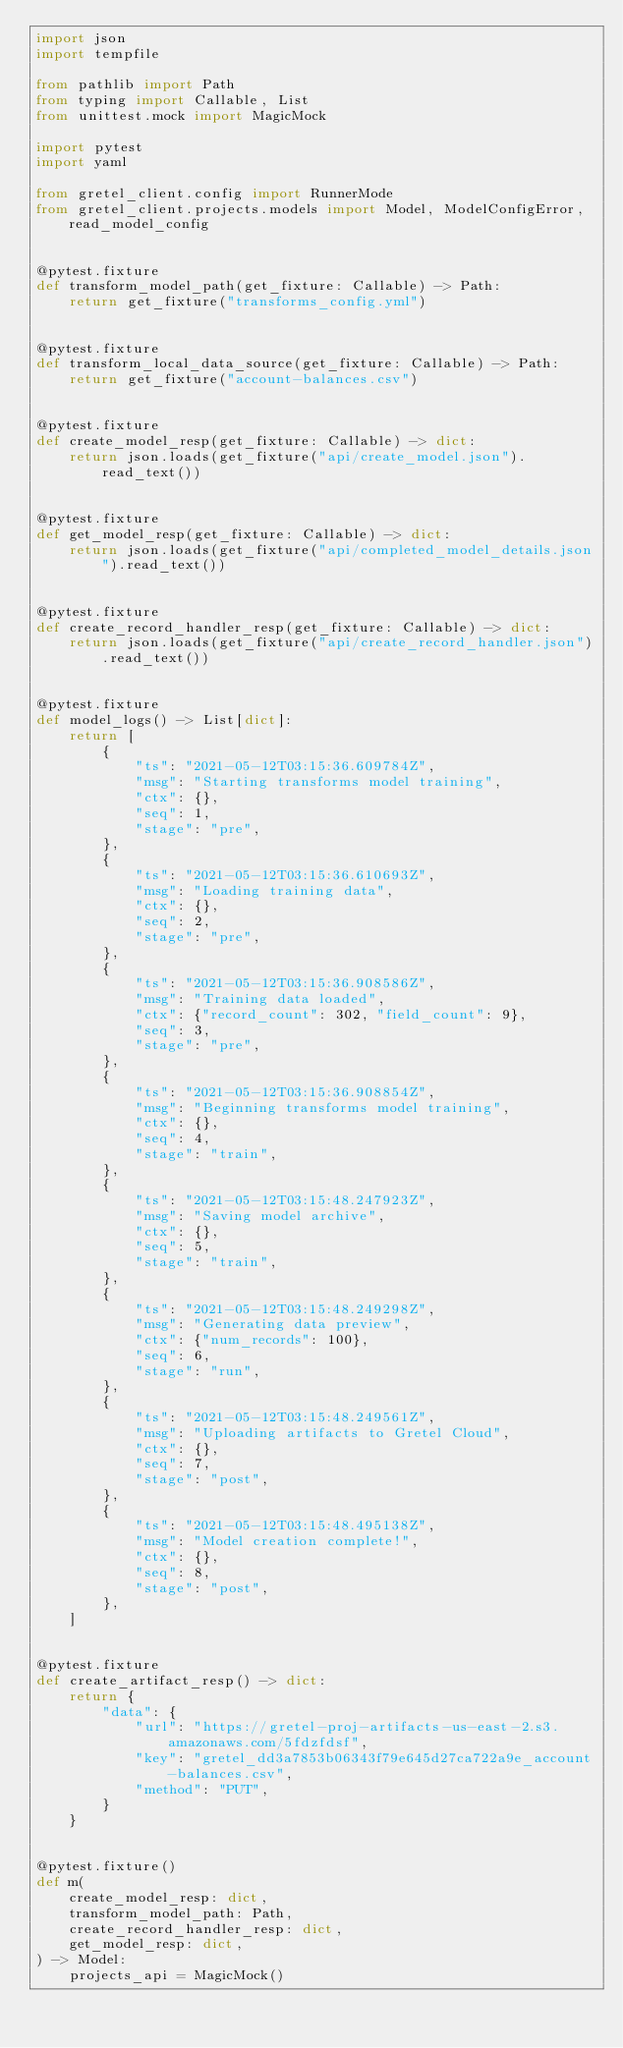<code> <loc_0><loc_0><loc_500><loc_500><_Python_>import json
import tempfile

from pathlib import Path
from typing import Callable, List
from unittest.mock import MagicMock

import pytest
import yaml

from gretel_client.config import RunnerMode
from gretel_client.projects.models import Model, ModelConfigError, read_model_config


@pytest.fixture
def transform_model_path(get_fixture: Callable) -> Path:
    return get_fixture("transforms_config.yml")


@pytest.fixture
def transform_local_data_source(get_fixture: Callable) -> Path:
    return get_fixture("account-balances.csv")


@pytest.fixture
def create_model_resp(get_fixture: Callable) -> dict:
    return json.loads(get_fixture("api/create_model.json").read_text())


@pytest.fixture
def get_model_resp(get_fixture: Callable) -> dict:
    return json.loads(get_fixture("api/completed_model_details.json").read_text())


@pytest.fixture
def create_record_handler_resp(get_fixture: Callable) -> dict:
    return json.loads(get_fixture("api/create_record_handler.json").read_text())


@pytest.fixture
def model_logs() -> List[dict]:
    return [
        {
            "ts": "2021-05-12T03:15:36.609784Z",
            "msg": "Starting transforms model training",
            "ctx": {},
            "seq": 1,
            "stage": "pre",
        },
        {
            "ts": "2021-05-12T03:15:36.610693Z",
            "msg": "Loading training data",
            "ctx": {},
            "seq": 2,
            "stage": "pre",
        },
        {
            "ts": "2021-05-12T03:15:36.908586Z",
            "msg": "Training data loaded",
            "ctx": {"record_count": 302, "field_count": 9},
            "seq": 3,
            "stage": "pre",
        },
        {
            "ts": "2021-05-12T03:15:36.908854Z",
            "msg": "Beginning transforms model training",
            "ctx": {},
            "seq": 4,
            "stage": "train",
        },
        {
            "ts": "2021-05-12T03:15:48.247923Z",
            "msg": "Saving model archive",
            "ctx": {},
            "seq": 5,
            "stage": "train",
        },
        {
            "ts": "2021-05-12T03:15:48.249298Z",
            "msg": "Generating data preview",
            "ctx": {"num_records": 100},
            "seq": 6,
            "stage": "run",
        },
        {
            "ts": "2021-05-12T03:15:48.249561Z",
            "msg": "Uploading artifacts to Gretel Cloud",
            "ctx": {},
            "seq": 7,
            "stage": "post",
        },
        {
            "ts": "2021-05-12T03:15:48.495138Z",
            "msg": "Model creation complete!",
            "ctx": {},
            "seq": 8,
            "stage": "post",
        },
    ]


@pytest.fixture
def create_artifact_resp() -> dict:
    return {
        "data": {
            "url": "https://gretel-proj-artifacts-us-east-2.s3.amazonaws.com/5fdzfdsf",
            "key": "gretel_dd3a7853b06343f79e645d27ca722a9e_account-balances.csv",
            "method": "PUT",
        }
    }


@pytest.fixture()
def m(
    create_model_resp: dict,
    transform_model_path: Path,
    create_record_handler_resp: dict,
    get_model_resp: dict,
) -> Model:
    projects_api = MagicMock()</code> 